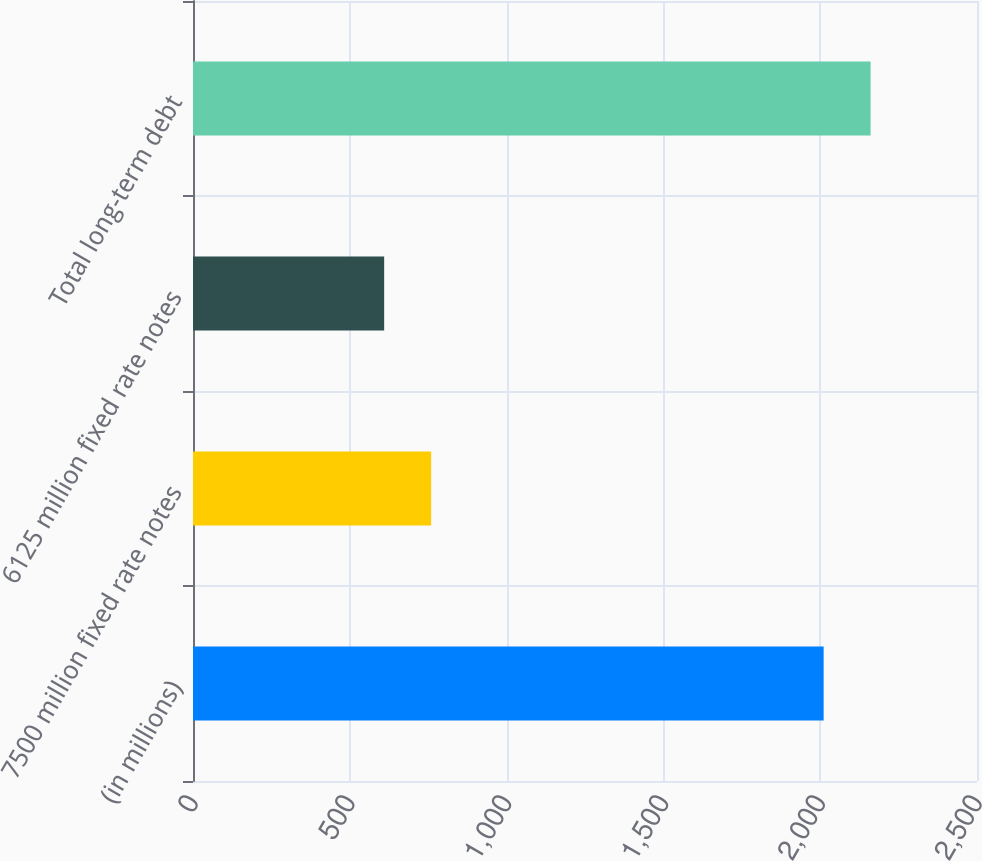Convert chart to OTSL. <chart><loc_0><loc_0><loc_500><loc_500><bar_chart><fcel>(in millions)<fcel>7500 million fixed rate notes<fcel>6125 million fixed rate notes<fcel>Total long-term debt<nl><fcel>2011<fcel>759.32<fcel>609.6<fcel>2160.72<nl></chart> 